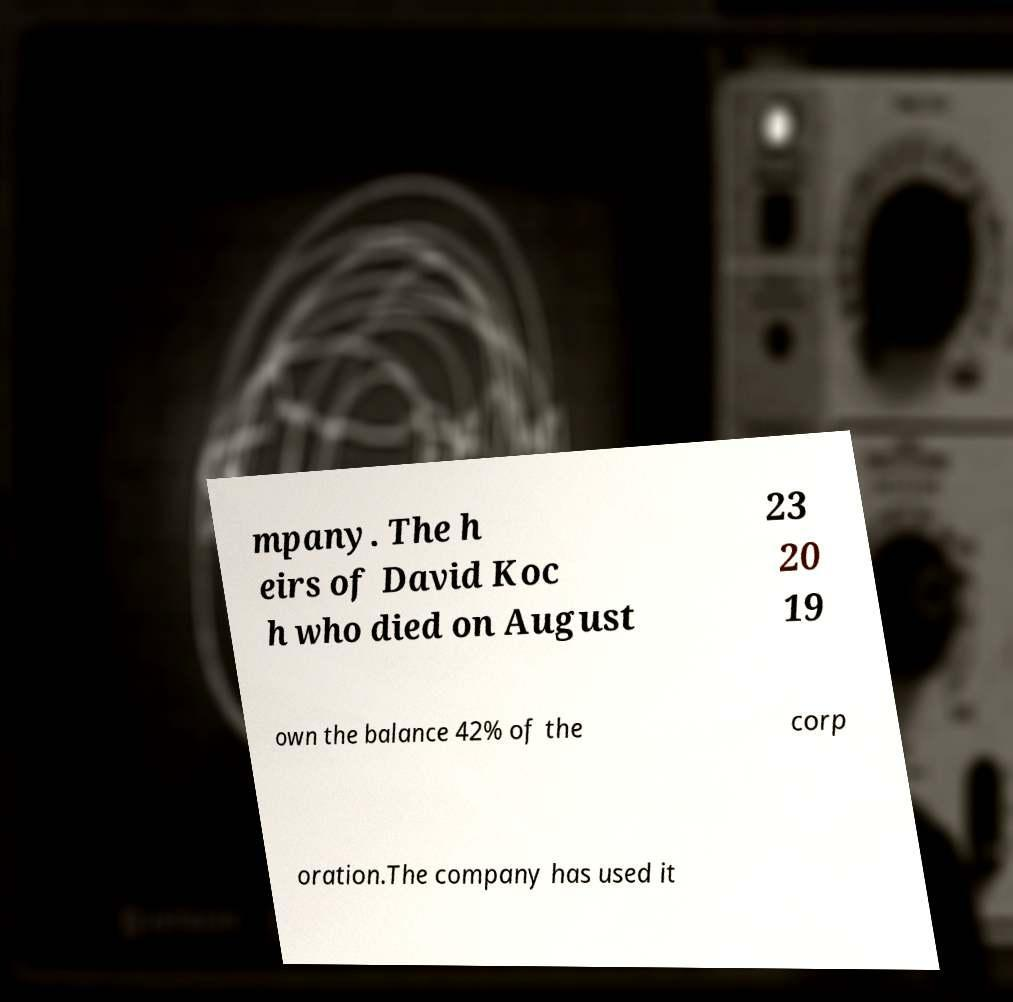Can you read and provide the text displayed in the image?This photo seems to have some interesting text. Can you extract and type it out for me? mpany. The h eirs of David Koc h who died on August 23 20 19 own the balance 42% of the corp oration.The company has used it 